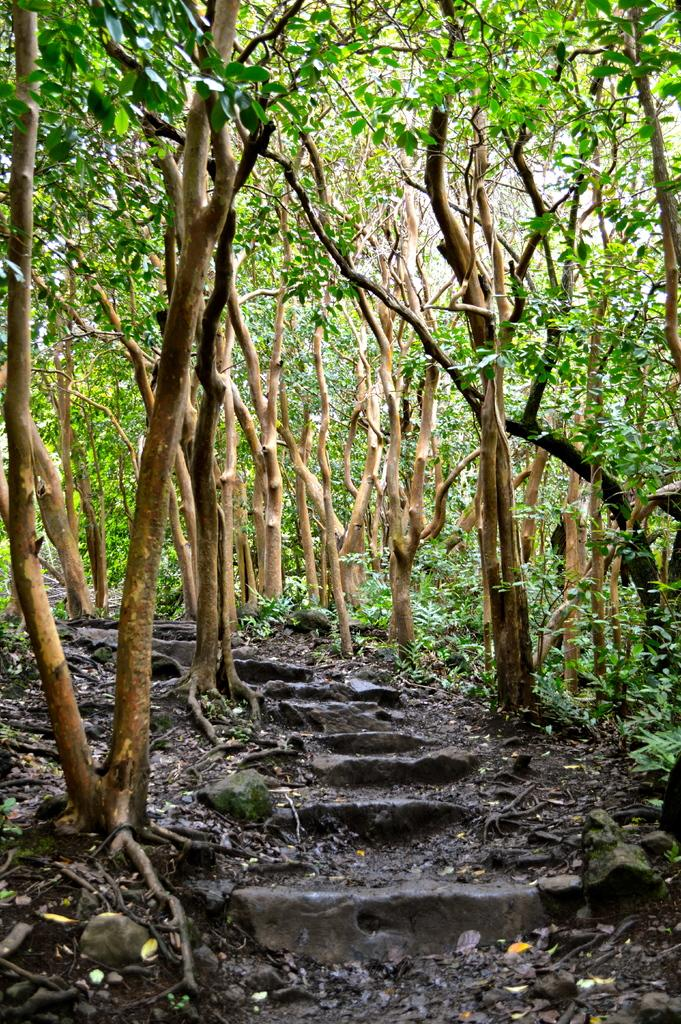What can be seen on the ground at the bottom of the image? There are steps on the ground at the bottom of the image. What else is present on the ground in the image? There are dry leaves on the ground. What type of vegetation is visible in the image? There are trees in the image. What invention is being demonstrated by the farmer in the image? There is no farmer or invention present in the image. Can you tell me how many people are swimming in the image? There is no swimming or people visible in the image. 